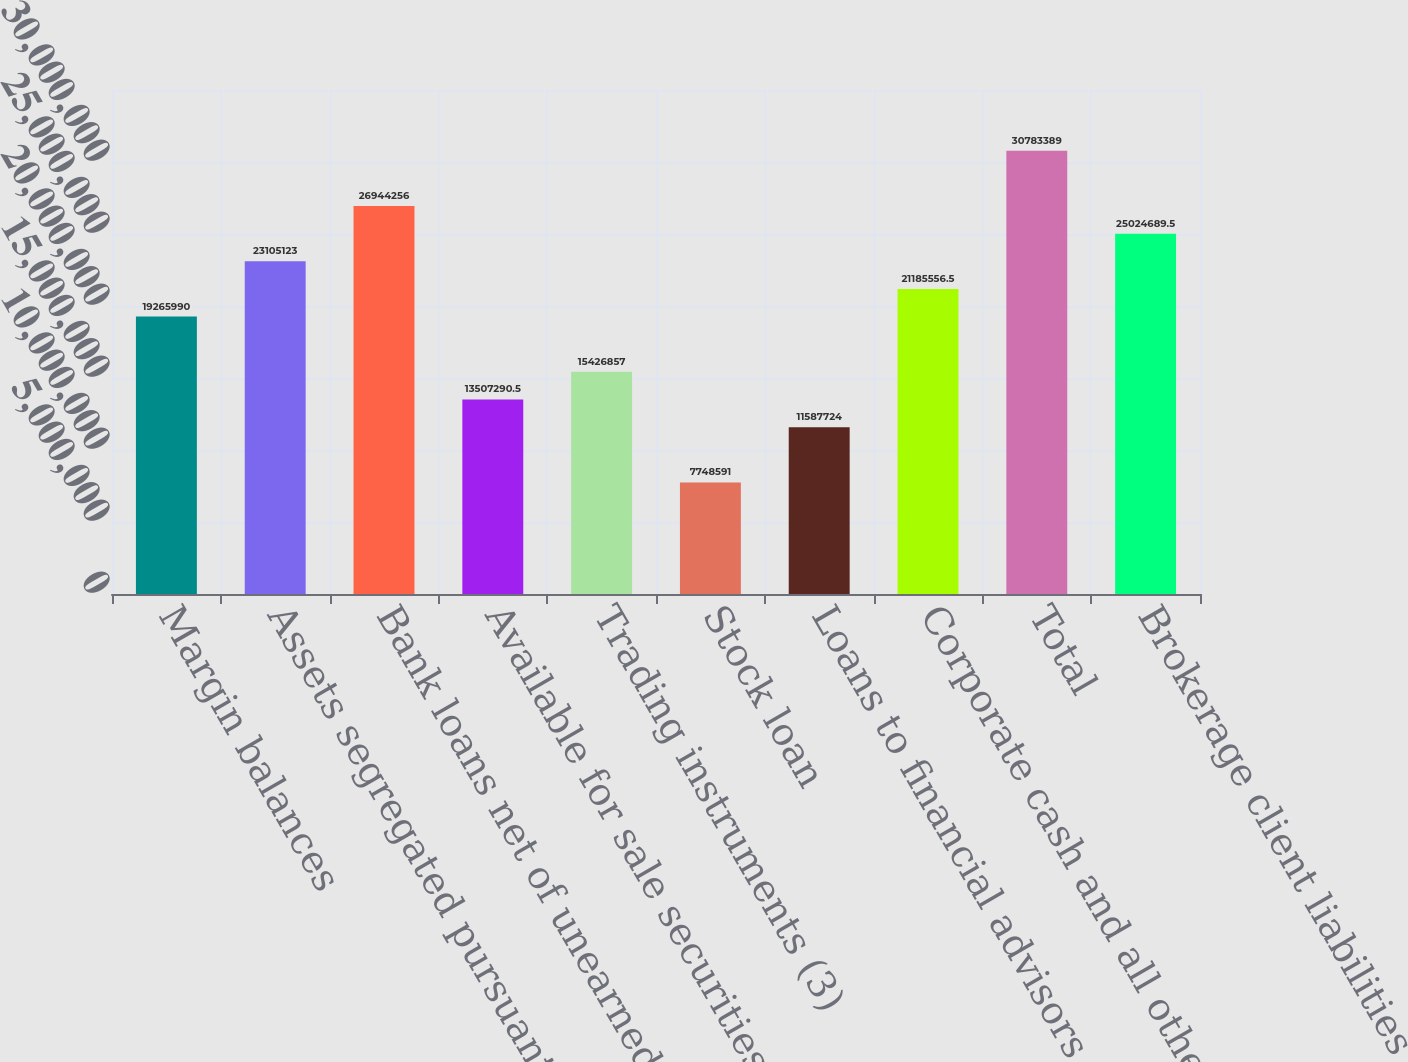Convert chart to OTSL. <chart><loc_0><loc_0><loc_500><loc_500><bar_chart><fcel>Margin balances<fcel>Assets segregated pursuant to<fcel>Bank loans net of unearned<fcel>Available for sale securities<fcel>Trading instruments (3)<fcel>Stock loan<fcel>Loans to financial advisors<fcel>Corporate cash and all other<fcel>Total<fcel>Brokerage client liabilities<nl><fcel>1.9266e+07<fcel>2.31051e+07<fcel>2.69443e+07<fcel>1.35073e+07<fcel>1.54269e+07<fcel>7.74859e+06<fcel>1.15877e+07<fcel>2.11856e+07<fcel>3.07834e+07<fcel>2.50247e+07<nl></chart> 